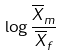<formula> <loc_0><loc_0><loc_500><loc_500>\log \frac { \overline { X } _ { m } } { \overline { X } _ { f } }</formula> 